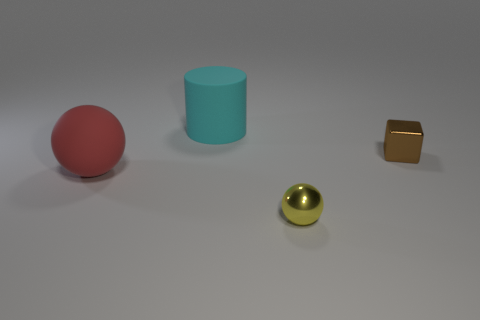What material is the yellow object that is the same shape as the large red thing?
Provide a short and direct response. Metal. There is a large object that is behind the shiny thing to the right of the small yellow thing; what is it made of?
Your answer should be very brief. Rubber. There is a yellow thing; is its shape the same as the large object that is in front of the cyan cylinder?
Your answer should be very brief. Yes. What number of shiny objects are tiny red objects or large cylinders?
Provide a succinct answer. 0. What color is the ball that is in front of the big sphere behind the sphere that is in front of the red thing?
Offer a terse response. Yellow. What number of other things are there of the same material as the block
Provide a succinct answer. 1. Do the tiny shiny object on the left side of the brown shiny object and the large red thing have the same shape?
Your answer should be compact. Yes. How many tiny objects are red balls or cyan matte cubes?
Offer a terse response. 0. Is the number of rubber spheres behind the brown shiny thing the same as the number of things in front of the red sphere?
Provide a succinct answer. No. What number of other things are the same color as the metal sphere?
Make the answer very short. 0. 